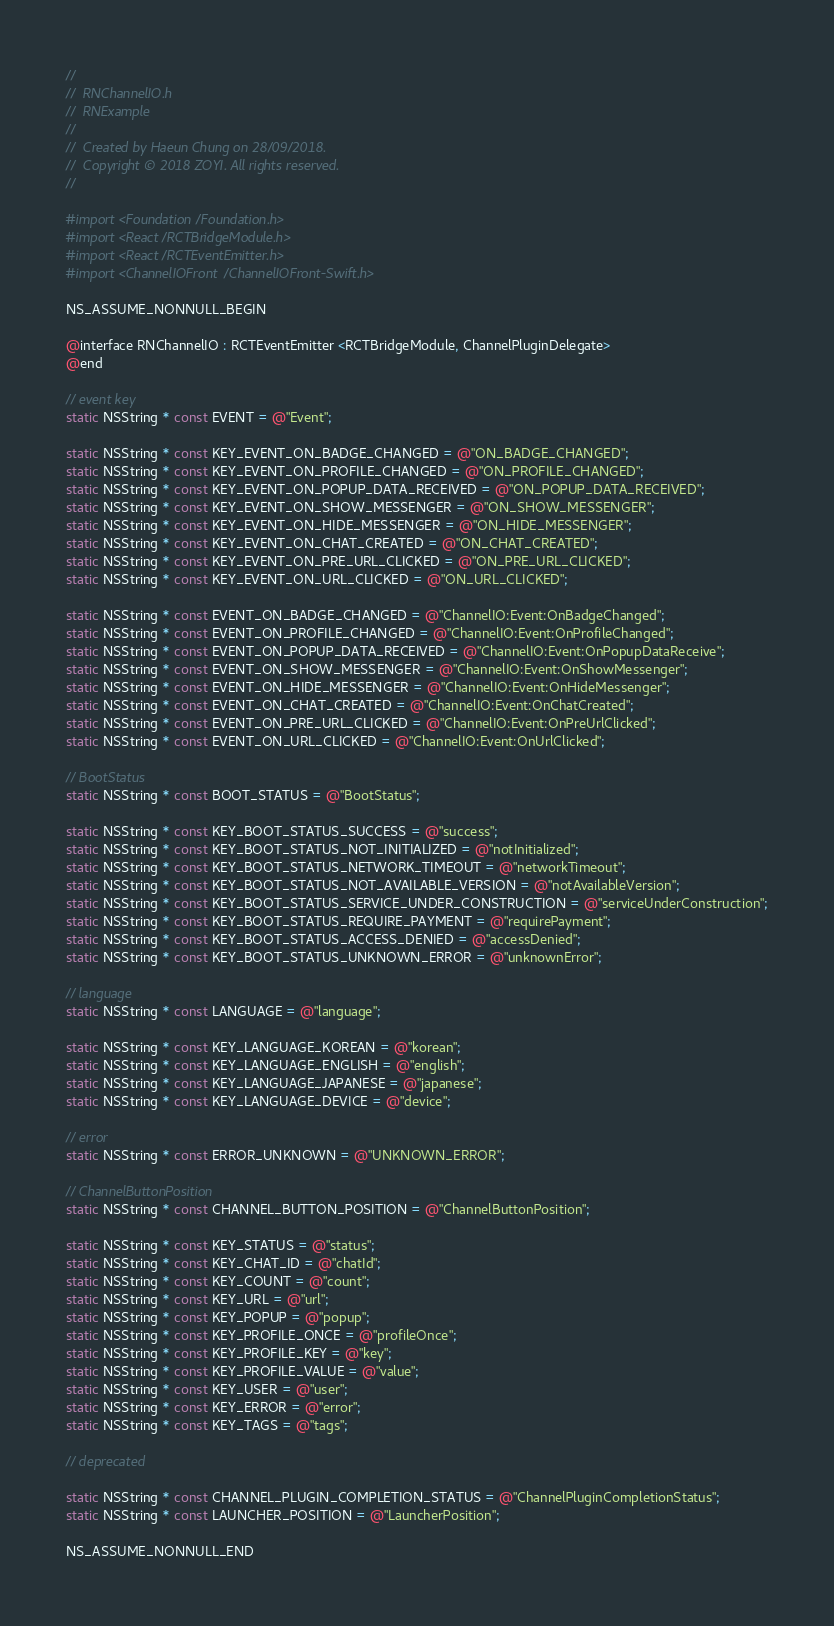Convert code to text. <code><loc_0><loc_0><loc_500><loc_500><_C_>//
//  RNChannelIO.h
//  RNExample
//
//  Created by Haeun Chung on 28/09/2018.
//  Copyright © 2018 ZOYI. All rights reserved.
//

#import <Foundation/Foundation.h>
#import <React/RCTBridgeModule.h>
#import <React/RCTEventEmitter.h>
#import <ChannelIOFront/ChannelIOFront-Swift.h>

NS_ASSUME_NONNULL_BEGIN

@interface RNChannelIO : RCTEventEmitter <RCTBridgeModule, ChannelPluginDelegate>
@end

// event key
static NSString * const EVENT = @"Event";

static NSString * const KEY_EVENT_ON_BADGE_CHANGED = @"ON_BADGE_CHANGED";
static NSString * const KEY_EVENT_ON_PROFILE_CHANGED = @"ON_PROFILE_CHANGED";
static NSString * const KEY_EVENT_ON_POPUP_DATA_RECEIVED = @"ON_POPUP_DATA_RECEIVED";
static NSString * const KEY_EVENT_ON_SHOW_MESSENGER = @"ON_SHOW_MESSENGER";
static NSString * const KEY_EVENT_ON_HIDE_MESSENGER = @"ON_HIDE_MESSENGER";
static NSString * const KEY_EVENT_ON_CHAT_CREATED = @"ON_CHAT_CREATED";
static NSString * const KEY_EVENT_ON_PRE_URL_CLICKED = @"ON_PRE_URL_CLICKED";
static NSString * const KEY_EVENT_ON_URL_CLICKED = @"ON_URL_CLICKED";

static NSString * const EVENT_ON_BADGE_CHANGED = @"ChannelIO:Event:OnBadgeChanged";
static NSString * const EVENT_ON_PROFILE_CHANGED = @"ChannelIO:Event:OnProfileChanged";
static NSString * const EVENT_ON_POPUP_DATA_RECEIVED = @"ChannelIO:Event:OnPopupDataReceive";
static NSString * const EVENT_ON_SHOW_MESSENGER = @"ChannelIO:Event:OnShowMessenger";
static NSString * const EVENT_ON_HIDE_MESSENGER = @"ChannelIO:Event:OnHideMessenger";
static NSString * const EVENT_ON_CHAT_CREATED = @"ChannelIO:Event:OnChatCreated";
static NSString * const EVENT_ON_PRE_URL_CLICKED = @"ChannelIO:Event:OnPreUrlClicked";
static NSString * const EVENT_ON_URL_CLICKED = @"ChannelIO:Event:OnUrlClicked";

// BootStatus
static NSString * const BOOT_STATUS = @"BootStatus";

static NSString * const KEY_BOOT_STATUS_SUCCESS = @"success";
static NSString * const KEY_BOOT_STATUS_NOT_INITIALIZED = @"notInitialized";
static NSString * const KEY_BOOT_STATUS_NETWORK_TIMEOUT = @"networkTimeout";
static NSString * const KEY_BOOT_STATUS_NOT_AVAILABLE_VERSION = @"notAvailableVersion";
static NSString * const KEY_BOOT_STATUS_SERVICE_UNDER_CONSTRUCTION = @"serviceUnderConstruction";
static NSString * const KEY_BOOT_STATUS_REQUIRE_PAYMENT = @"requirePayment";
static NSString * const KEY_BOOT_STATUS_ACCESS_DENIED = @"accessDenied";
static NSString * const KEY_BOOT_STATUS_UNKNOWN_ERROR = @"unknownError";

// language
static NSString * const LANGUAGE = @"language";

static NSString * const KEY_LANGUAGE_KOREAN = @"korean";
static NSString * const KEY_LANGUAGE_ENGLISH = @"english";
static NSString * const KEY_LANGUAGE_JAPANESE = @"japanese";
static NSString * const KEY_LANGUAGE_DEVICE = @"device";

// error
static NSString * const ERROR_UNKNOWN = @"UNKNOWN_ERROR";

// ChannelButtonPosition
static NSString * const CHANNEL_BUTTON_POSITION = @"ChannelButtonPosition";

static NSString * const KEY_STATUS = @"status";
static NSString * const KEY_CHAT_ID = @"chatId";
static NSString * const KEY_COUNT = @"count";
static NSString * const KEY_URL = @"url";
static NSString * const KEY_POPUP = @"popup";
static NSString * const KEY_PROFILE_ONCE = @"profileOnce";
static NSString * const KEY_PROFILE_KEY = @"key";
static NSString * const KEY_PROFILE_VALUE = @"value";
static NSString * const KEY_USER = @"user";
static NSString * const KEY_ERROR = @"error";
static NSString * const KEY_TAGS = @"tags";

// deprecated

static NSString * const CHANNEL_PLUGIN_COMPLETION_STATUS = @"ChannelPluginCompletionStatus";
static NSString * const LAUNCHER_POSITION = @"LauncherPosition";

NS_ASSUME_NONNULL_END
</code> 